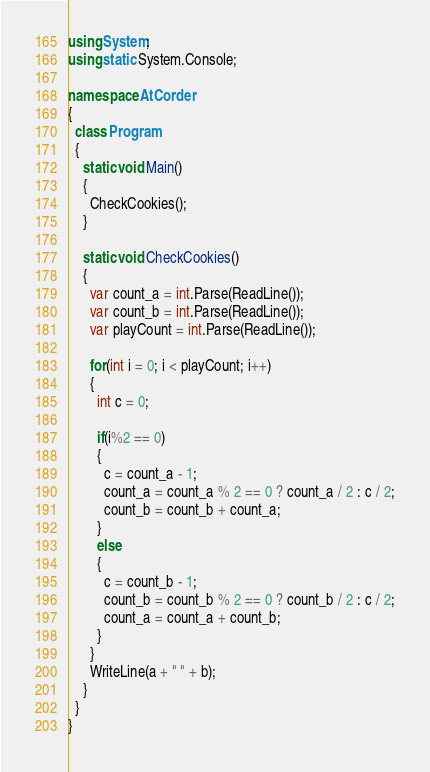Convert code to text. <code><loc_0><loc_0><loc_500><loc_500><_C#_>using System;
using static System.Console;

namespace AtCorder
{
  class Program
  {
    static void Main()
    {
      CheckCookies();
    }

    static void CheckCookies()
    {
      var count_a = int.Parse(ReadLine());
      var count_b = int.Parse(ReadLine());
      var playCount = int.Parse(ReadLine());

      for(int i = 0; i < playCount; i++)
      {
        int c = 0;

        if(i%2 == 0)
        {
          c = count_a - 1;
          count_a = count_a % 2 == 0 ? count_a / 2 : c / 2;
          count_b = count_b + count_a;
        } 
        else
        {
          c = count_b - 1;
          count_b = count_b % 2 == 0 ? count_b / 2 : c / 2;
          count_a = count_a + count_b;
        } 
      }
      WriteLine(a + " " + b);
    }
  }
}</code> 